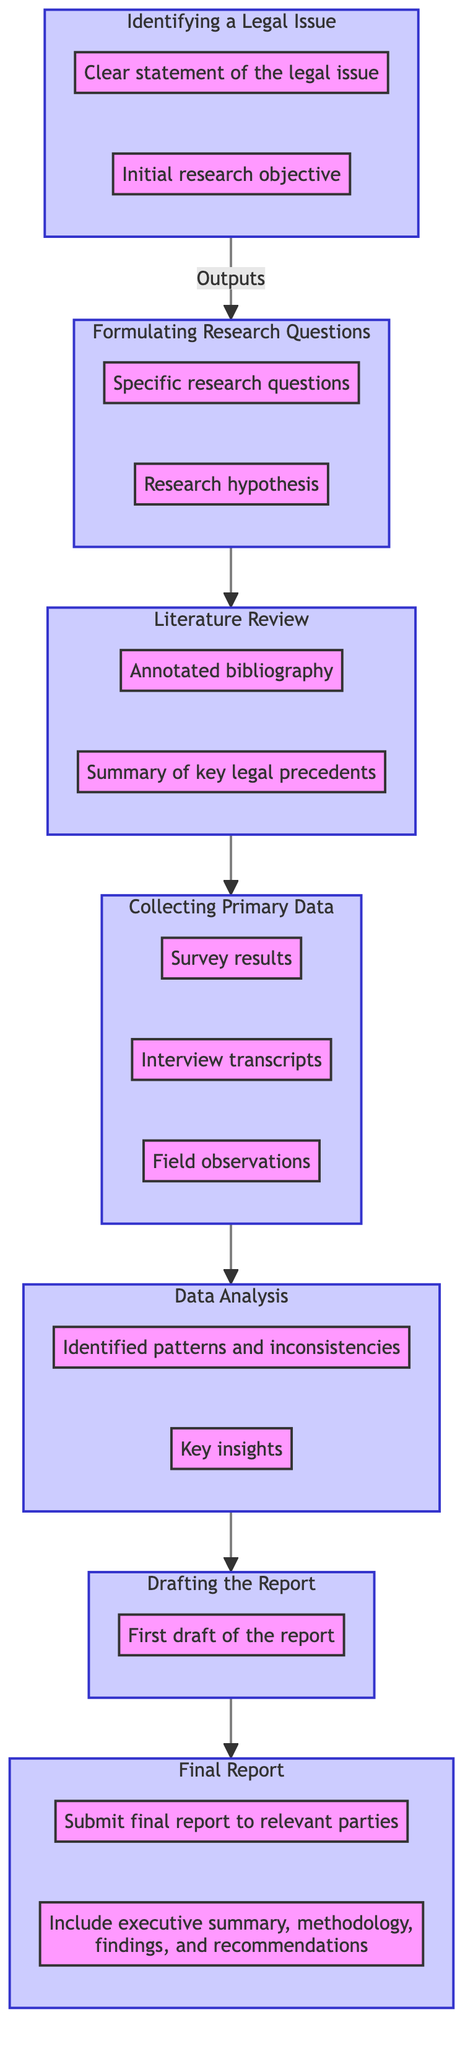What is the first step in the legal research process? The first step is "Identifying a Legal Issue" as shown in the bottom node of the flowchart, which indicates the starting point of the research process.
Answer: Identifying a Legal Issue How many outputs are there for the "Final Report"? By checking the "Final Report" node, there are two outputs listed: "Submit final report to relevant parties" and "Include executive summary, methodology, findings, and recommendations".
Answer: 2 What is the output of the "Data Analysis" step? The "Data Analysis" node has two outputs: "Identified patterns and inconsistencies" and "Key insights". This means after analyzing the collected data, these insights are produced.
Answer: Identified patterns and inconsistencies, Key insights What are the outputs of the "Collecting Primary Data" step? In the "Collecting Primary Data" node, there are three outputs mentioned: "Survey results", "Interview transcripts", and "Field observations", indicating the types of primary data collected.
Answer: Survey results, Interview transcripts, Field observations Which step follows "Literature Review"? By following the flow from the "Literature Review" node, the next step indicated is "Collecting Primary Data". This illustrates the flow of the research process.
Answer: Collecting Primary Data How do you formulate research questions? To formulate research questions, one must first complete the "Identifying a Legal Issue", leading to the output of "Specific research questions" and "Research hypothesis" from the following step "Formulating Research Questions".
Answer: Specific research questions, Research hypothesis Which step involves analyzing data? The step that involves analyzing data is "Data Analysis", where collected data is processed to extract patterns and insights, as visualized in the diagram.
Answer: Data Analysis What role does the "Drafting the Report" step play? The "Drafting the Report" step organizes research data into a structured format leading to the creation of the "First draft of the report" as an output.
Answer: First draft of the report In which direction does the programming flowchart progress? The flowchart progresses from the bottom to the top, indicating that each step builds upon the previous one in the legal research process.
Answer: Bottom to top 